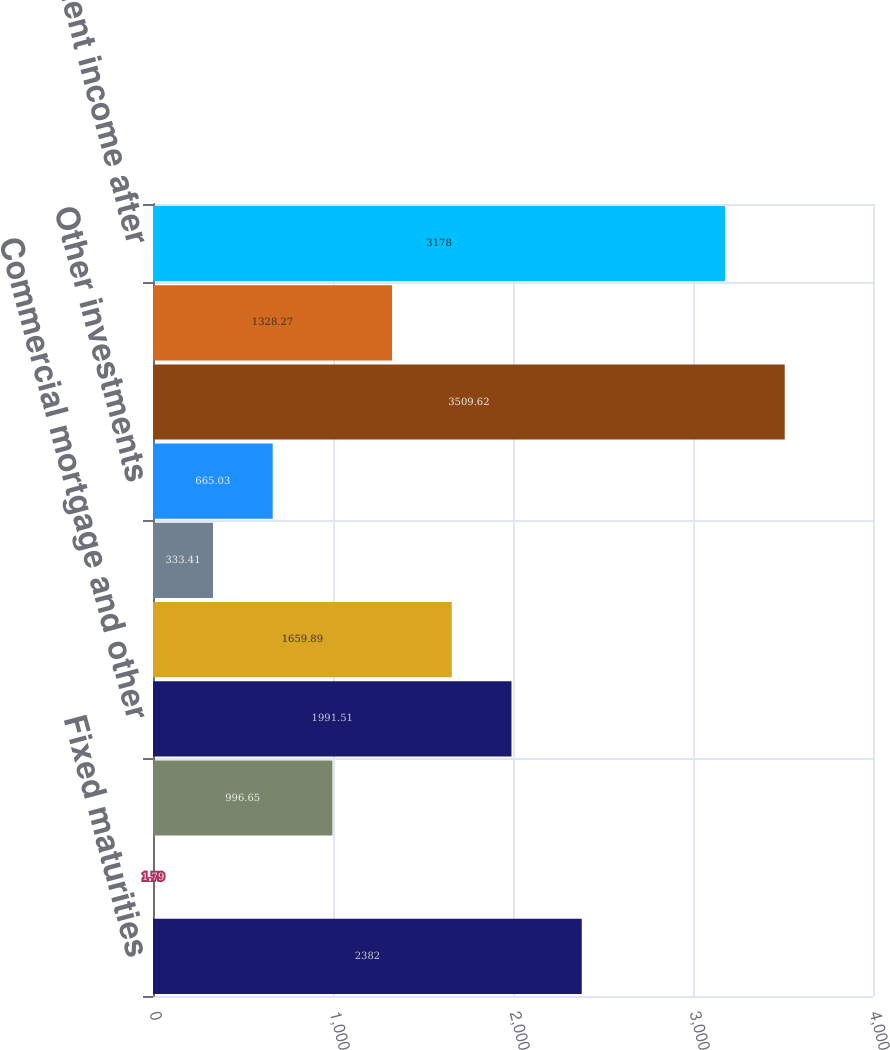Convert chart to OTSL. <chart><loc_0><loc_0><loc_500><loc_500><bar_chart><fcel>Fixed maturities<fcel>Trading account assets<fcel>Equity securities<fcel>Commercial mortgage and other<fcel>Policy loans<fcel>Short-term investments and<fcel>Other investments<fcel>Gross investment income before<fcel>Investment expenses<fcel>Investment income after<nl><fcel>2382<fcel>1.79<fcel>996.65<fcel>1991.51<fcel>1659.89<fcel>333.41<fcel>665.03<fcel>3509.62<fcel>1328.27<fcel>3178<nl></chart> 